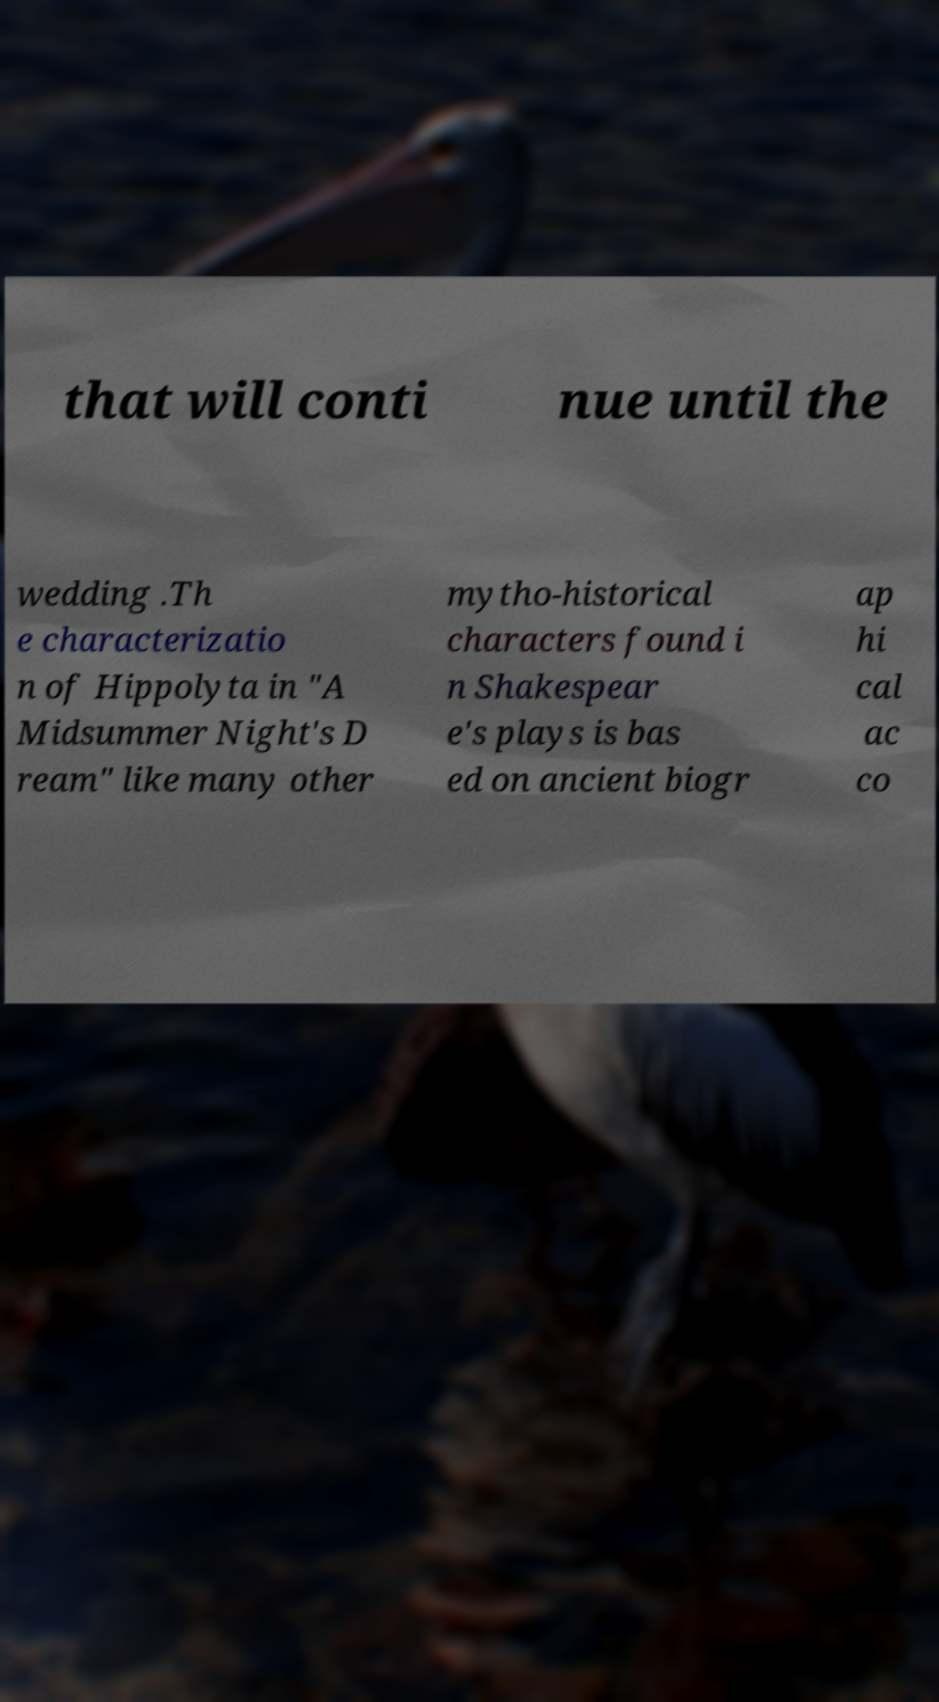What messages or text are displayed in this image? I need them in a readable, typed format. that will conti nue until the wedding .Th e characterizatio n of Hippolyta in "A Midsummer Night's D ream" like many other mytho-historical characters found i n Shakespear e's plays is bas ed on ancient biogr ap hi cal ac co 